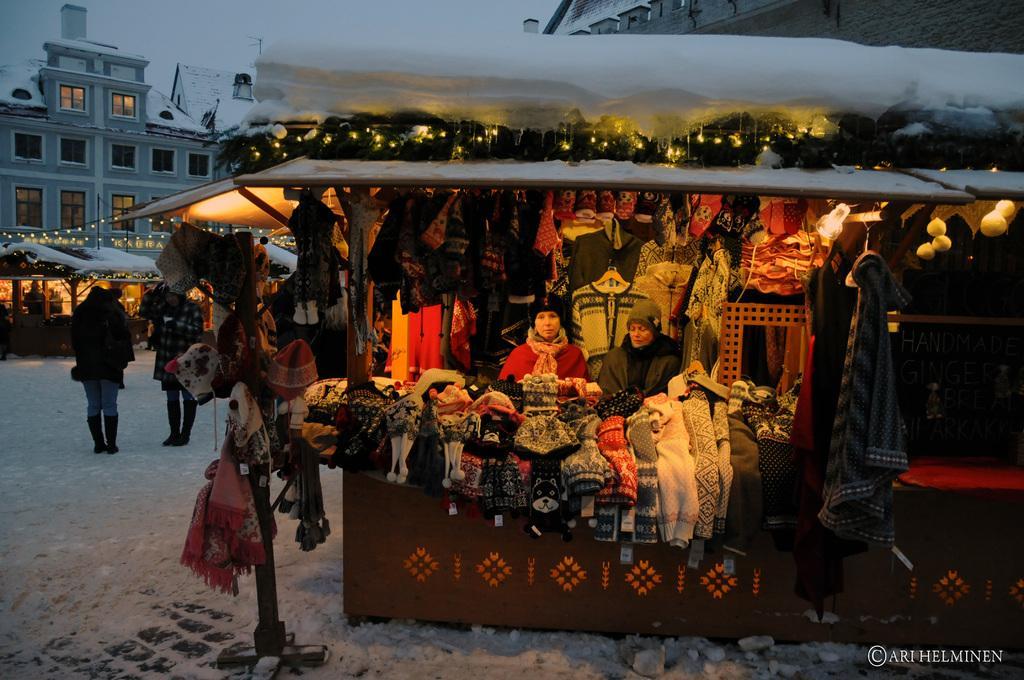Can you describe this image briefly? In this image there are two women standing in a stall, in the stall there are sweaters, gloves and mufflers, on top of the stall there is snow, at the bottom of the image there is some text, behind the stall there are two women standing on the snow surface, in front of them there are a few other stalls decorated with lights, behind the stalls there are buildings. 